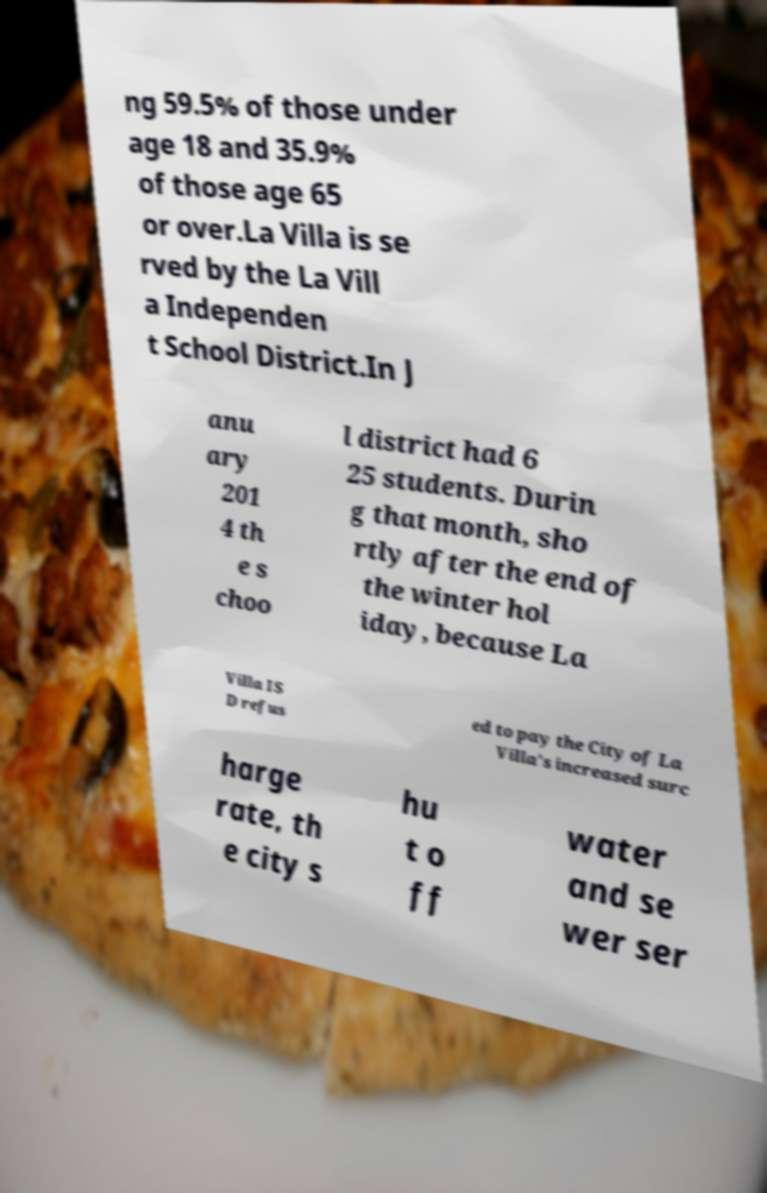For documentation purposes, I need the text within this image transcribed. Could you provide that? ng 59.5% of those under age 18 and 35.9% of those age 65 or over.La Villa is se rved by the La Vill a Independen t School District.In J anu ary 201 4 th e s choo l district had 6 25 students. Durin g that month, sho rtly after the end of the winter hol iday, because La Villa IS D refus ed to pay the City of La Villa's increased surc harge rate, th e city s hu t o ff water and se wer ser 